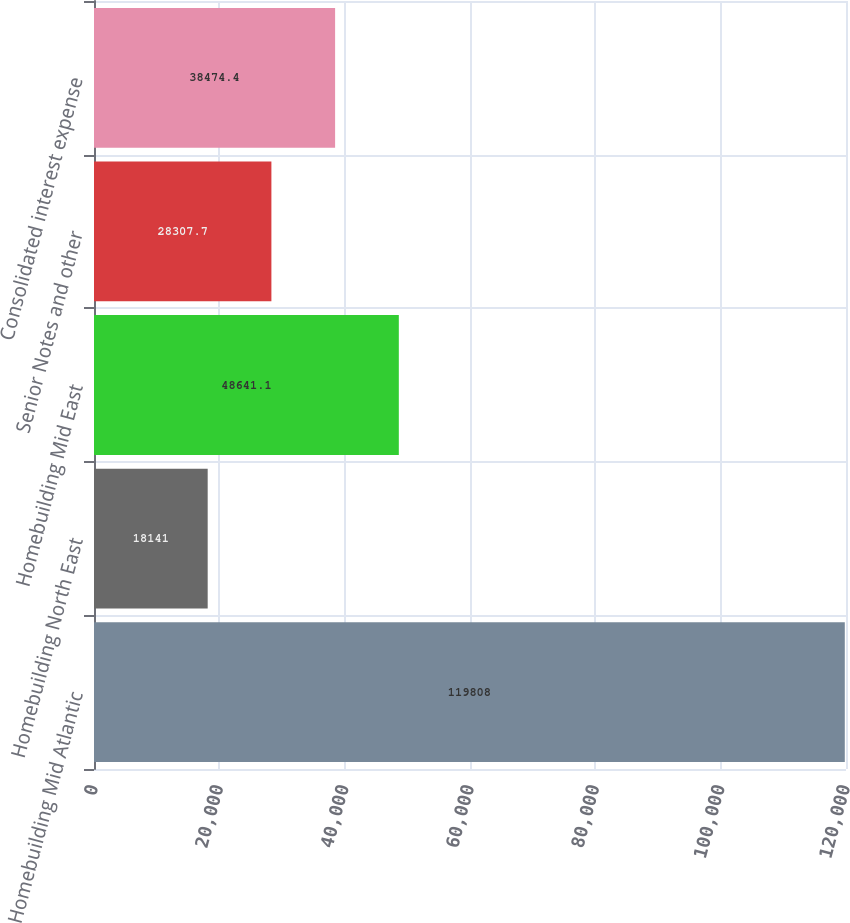<chart> <loc_0><loc_0><loc_500><loc_500><bar_chart><fcel>Homebuilding Mid Atlantic<fcel>Homebuilding North East<fcel>Homebuilding Mid East<fcel>Senior Notes and other<fcel>Consolidated interest expense<nl><fcel>119808<fcel>18141<fcel>48641.1<fcel>28307.7<fcel>38474.4<nl></chart> 